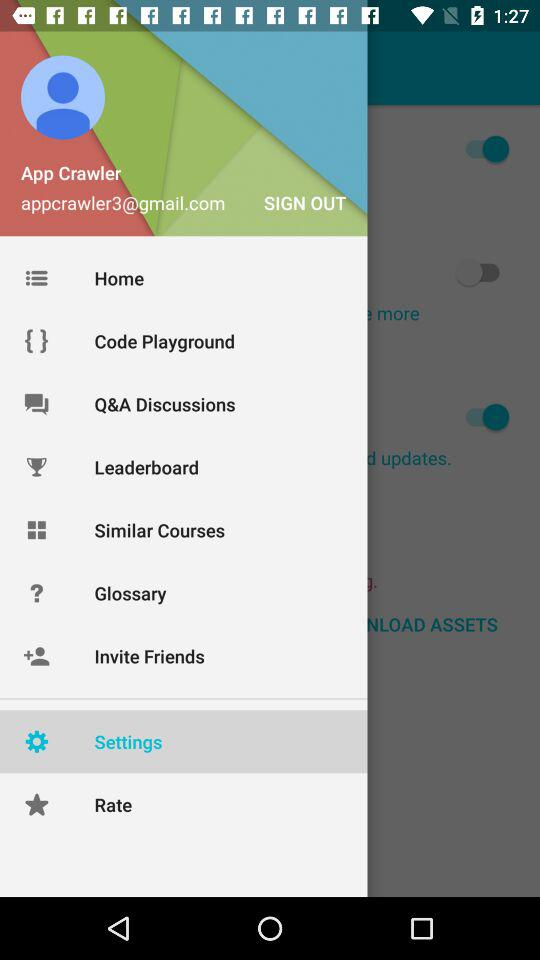What is the profile name? The profile name is App Crawler. 